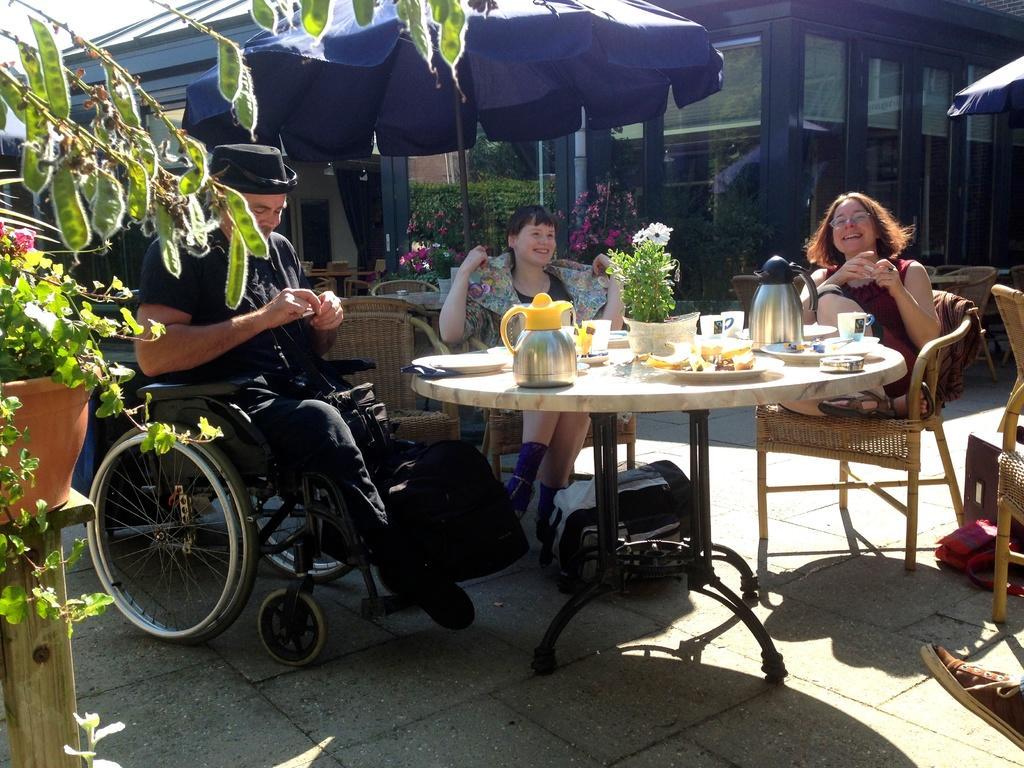In one or two sentences, can you explain what this image depicts? In the image we can see there are people who are sitting on chair and a man is sitting on wheel chair and on table there are water jug. In plates there are food items and cup. 